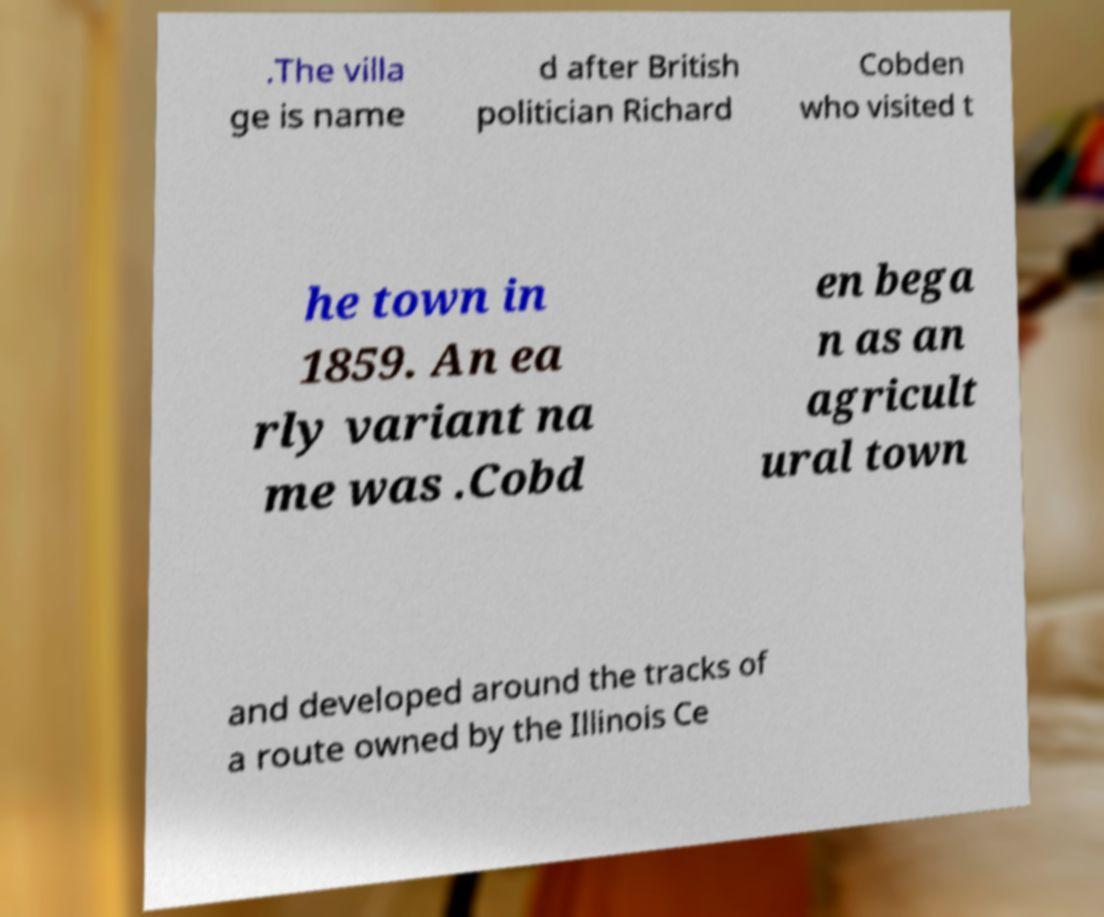There's text embedded in this image that I need extracted. Can you transcribe it verbatim? .The villa ge is name d after British politician Richard Cobden who visited t he town in 1859. An ea rly variant na me was .Cobd en bega n as an agricult ural town and developed around the tracks of a route owned by the Illinois Ce 